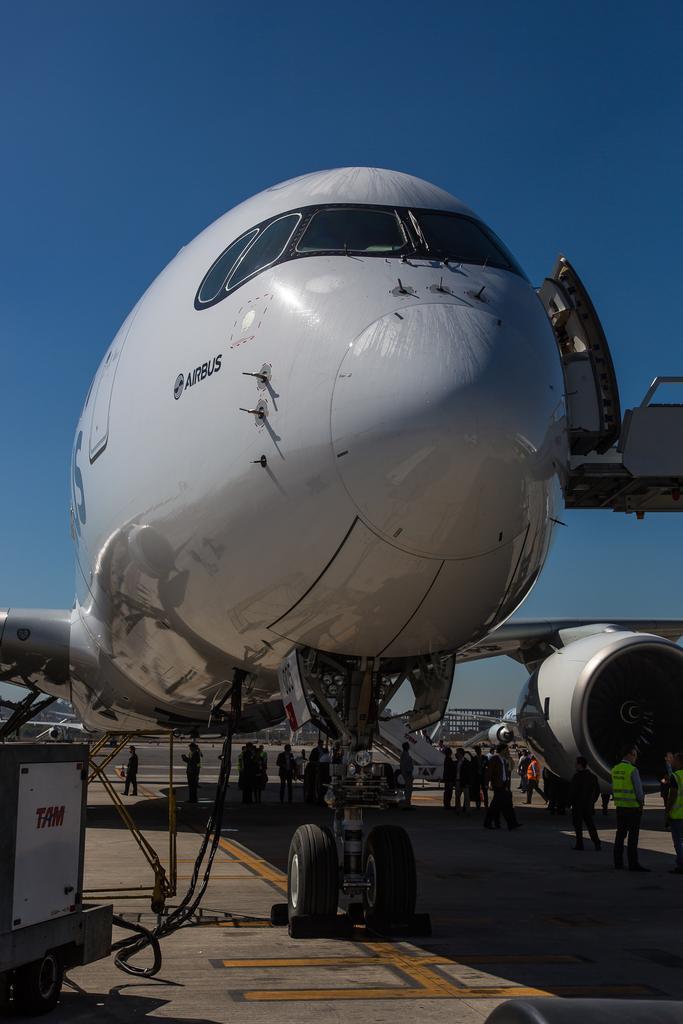Please provide a concise description of this image. Here we can see an aeroplane on the road and at the bottom there are few persons standing and walking on the road and on the left there is a vehicle and cables. In the background there is a building,trees and the sky. 